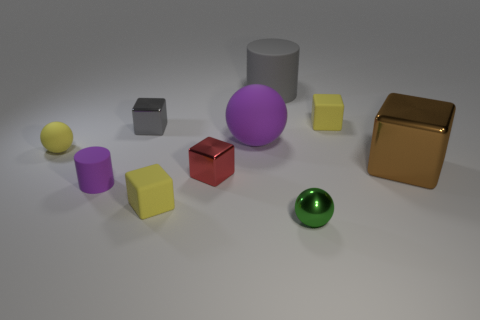Does the tiny red thing have the same material as the tiny ball that is behind the brown object?
Keep it short and to the point. No. How many other objects are there of the same size as the purple rubber cylinder?
Your response must be concise. 6. Is there a tiny purple cylinder on the left side of the tiny block on the right side of the metal object in front of the small purple matte thing?
Ensure brevity in your answer.  Yes. How big is the gray cylinder?
Provide a short and direct response. Large. There is a ball left of the gray metallic object; how big is it?
Offer a terse response. Small. There is a matte cube that is on the right side of the shiny ball; does it have the same size as the small shiny sphere?
Provide a succinct answer. Yes. Is there any other thing that is the same color as the big cube?
Keep it short and to the point. No. The brown thing is what shape?
Your response must be concise. Cube. How many cubes are left of the gray cylinder and behind the small rubber cylinder?
Give a very brief answer. 2. Is the large sphere the same color as the small cylinder?
Provide a short and direct response. Yes. 